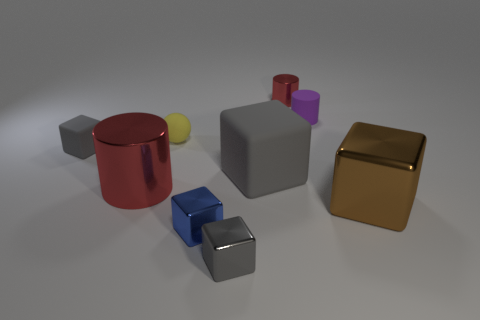Are there any other things that have the same color as the small matte sphere?
Give a very brief answer. No. There is a big cylinder; is its color the same as the shiny cylinder that is behind the small yellow rubber ball?
Provide a succinct answer. Yes. How many other objects are there of the same material as the blue cube?
Give a very brief answer. 4. Are there more blue things than large green matte blocks?
Give a very brief answer. Yes. Is the color of the metallic cylinder that is left of the blue metal object the same as the big matte thing?
Your response must be concise. No. The tiny metallic cylinder is what color?
Your answer should be compact. Red. Is there a blue metal thing that is to the right of the red shiny cylinder that is to the left of the tiny gray metal block?
Provide a succinct answer. Yes. There is a thing left of the red metallic cylinder to the left of the small sphere; what is its shape?
Make the answer very short. Cube. Are there fewer big metal objects than matte things?
Your answer should be very brief. Yes. Does the tiny blue object have the same material as the big gray block?
Ensure brevity in your answer.  No. 